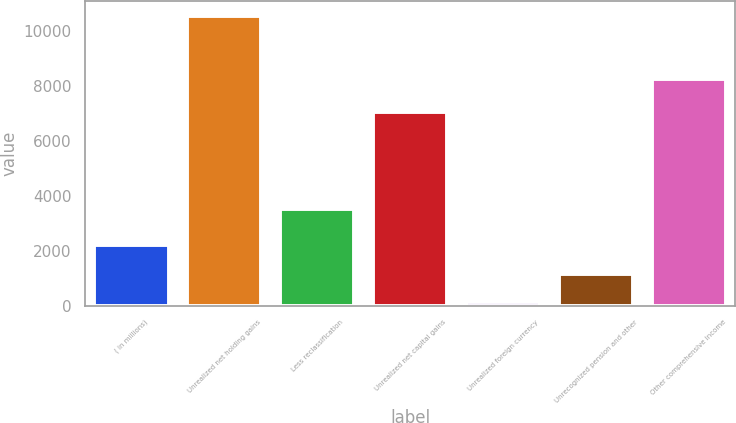<chart> <loc_0><loc_0><loc_500><loc_500><bar_chart><fcel>( in millions)<fcel>Unrealized net holding gains<fcel>Less reclassification<fcel>Unrealized net capital gains<fcel>Unrealized foreign currency<fcel>Unrecognized pension and other<fcel>Other comprehensive income<nl><fcel>2204.6<fcel>10567<fcel>3509<fcel>7058<fcel>114<fcel>1159.3<fcel>8275<nl></chart> 